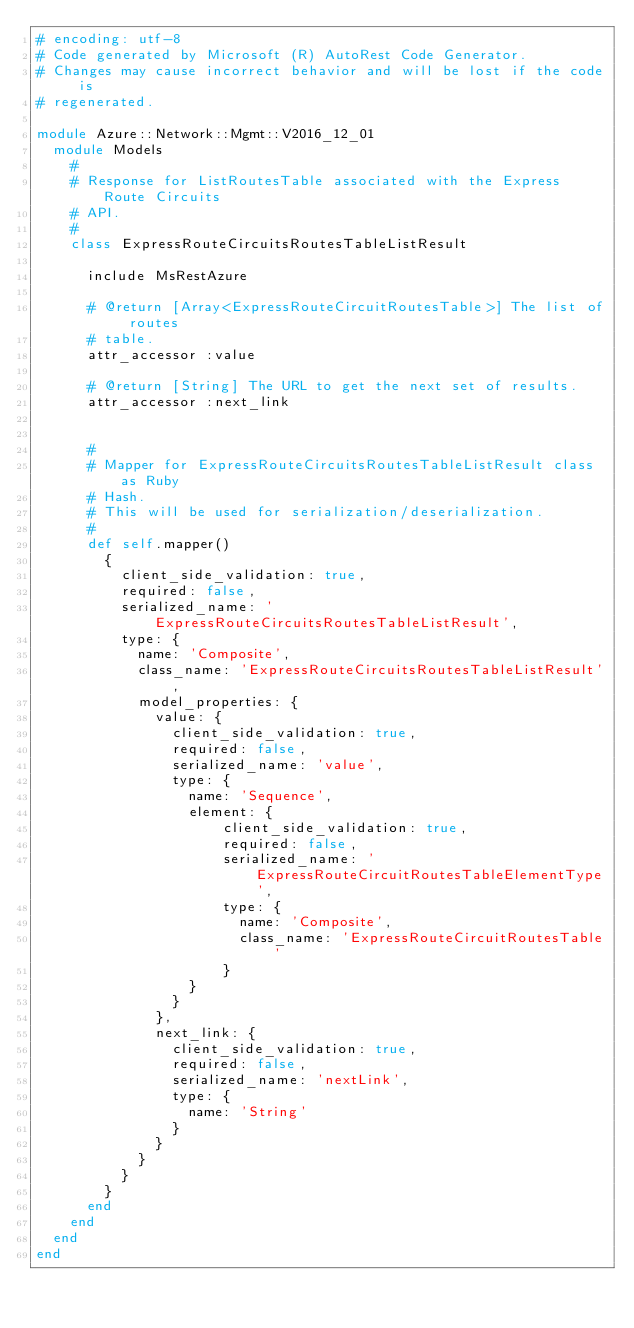Convert code to text. <code><loc_0><loc_0><loc_500><loc_500><_Ruby_># encoding: utf-8
# Code generated by Microsoft (R) AutoRest Code Generator.
# Changes may cause incorrect behavior and will be lost if the code is
# regenerated.

module Azure::Network::Mgmt::V2016_12_01
  module Models
    #
    # Response for ListRoutesTable associated with the Express Route Circuits
    # API.
    #
    class ExpressRouteCircuitsRoutesTableListResult

      include MsRestAzure

      # @return [Array<ExpressRouteCircuitRoutesTable>] The list of routes
      # table.
      attr_accessor :value

      # @return [String] The URL to get the next set of results.
      attr_accessor :next_link


      #
      # Mapper for ExpressRouteCircuitsRoutesTableListResult class as Ruby
      # Hash.
      # This will be used for serialization/deserialization.
      #
      def self.mapper()
        {
          client_side_validation: true,
          required: false,
          serialized_name: 'ExpressRouteCircuitsRoutesTableListResult',
          type: {
            name: 'Composite',
            class_name: 'ExpressRouteCircuitsRoutesTableListResult',
            model_properties: {
              value: {
                client_side_validation: true,
                required: false,
                serialized_name: 'value',
                type: {
                  name: 'Sequence',
                  element: {
                      client_side_validation: true,
                      required: false,
                      serialized_name: 'ExpressRouteCircuitRoutesTableElementType',
                      type: {
                        name: 'Composite',
                        class_name: 'ExpressRouteCircuitRoutesTable'
                      }
                  }
                }
              },
              next_link: {
                client_side_validation: true,
                required: false,
                serialized_name: 'nextLink',
                type: {
                  name: 'String'
                }
              }
            }
          }
        }
      end
    end
  end
end
</code> 